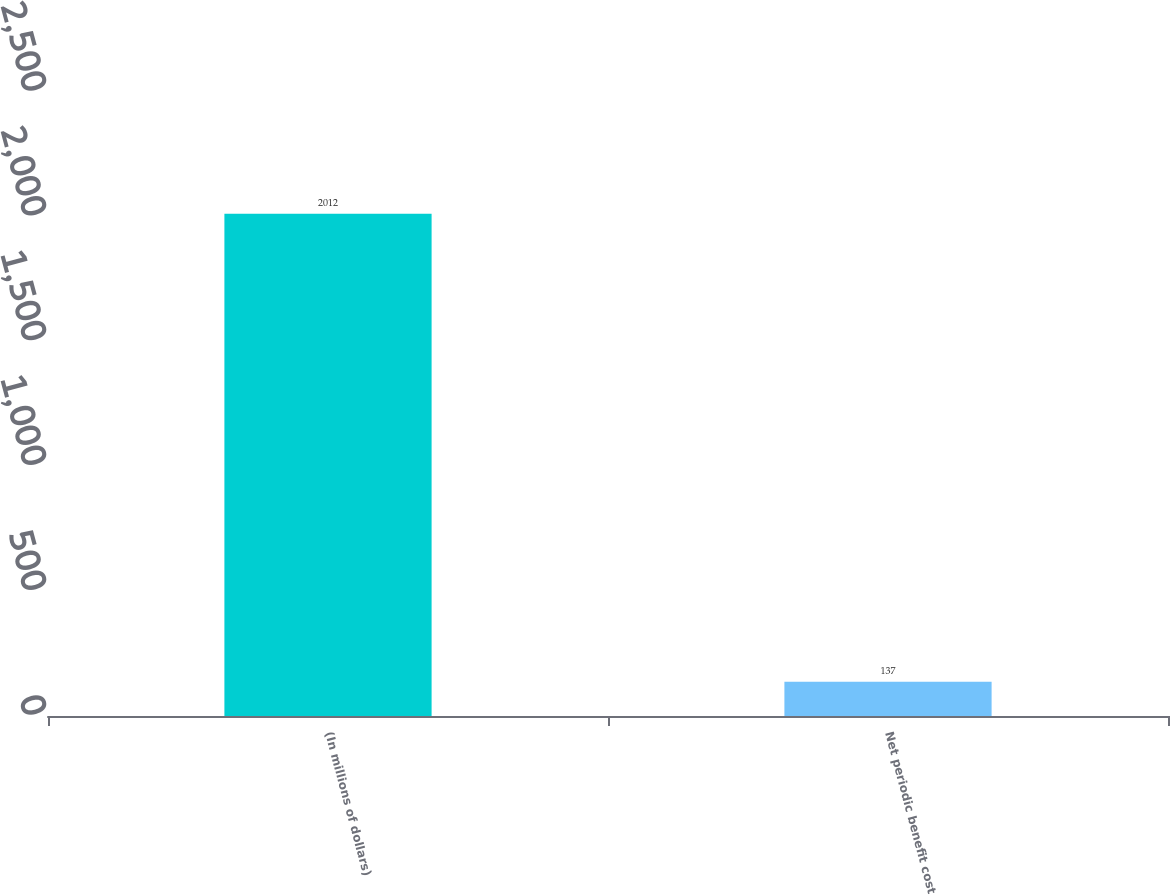Convert chart to OTSL. <chart><loc_0><loc_0><loc_500><loc_500><bar_chart><fcel>(In millions of dollars)<fcel>Net periodic benefit cost<nl><fcel>2012<fcel>137<nl></chart> 